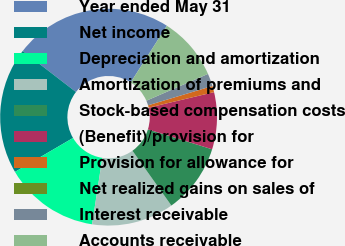<chart> <loc_0><loc_0><loc_500><loc_500><pie_chart><fcel>Year ended May 31<fcel>Net income<fcel>Depreciation and amortization<fcel>Amortization of premiums and<fcel>Stock-based compensation costs<fcel>(Benefit)/provision for<fcel>Provision for allowance for<fcel>Net realized gains on sales of<fcel>Interest receivable<fcel>Accounts receivable<nl><fcel>23.58%<fcel>18.87%<fcel>14.15%<fcel>12.26%<fcel>10.38%<fcel>8.49%<fcel>0.94%<fcel>0.0%<fcel>1.89%<fcel>9.43%<nl></chart> 